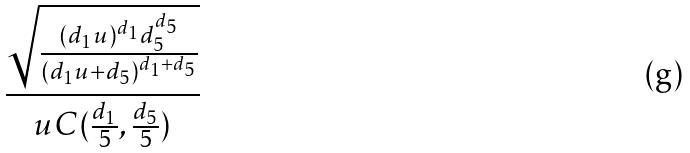Convert formula to latex. <formula><loc_0><loc_0><loc_500><loc_500>\frac { \sqrt { \frac { ( d _ { 1 } u ) ^ { d _ { 1 } } d _ { 5 } ^ { d _ { 5 } } } { ( d _ { 1 } u + d _ { 5 } ) ^ { d _ { 1 } + d _ { 5 } } } } } { u C ( \frac { d _ { 1 } } { 5 } , \frac { d _ { 5 } } { 5 } ) }</formula> 